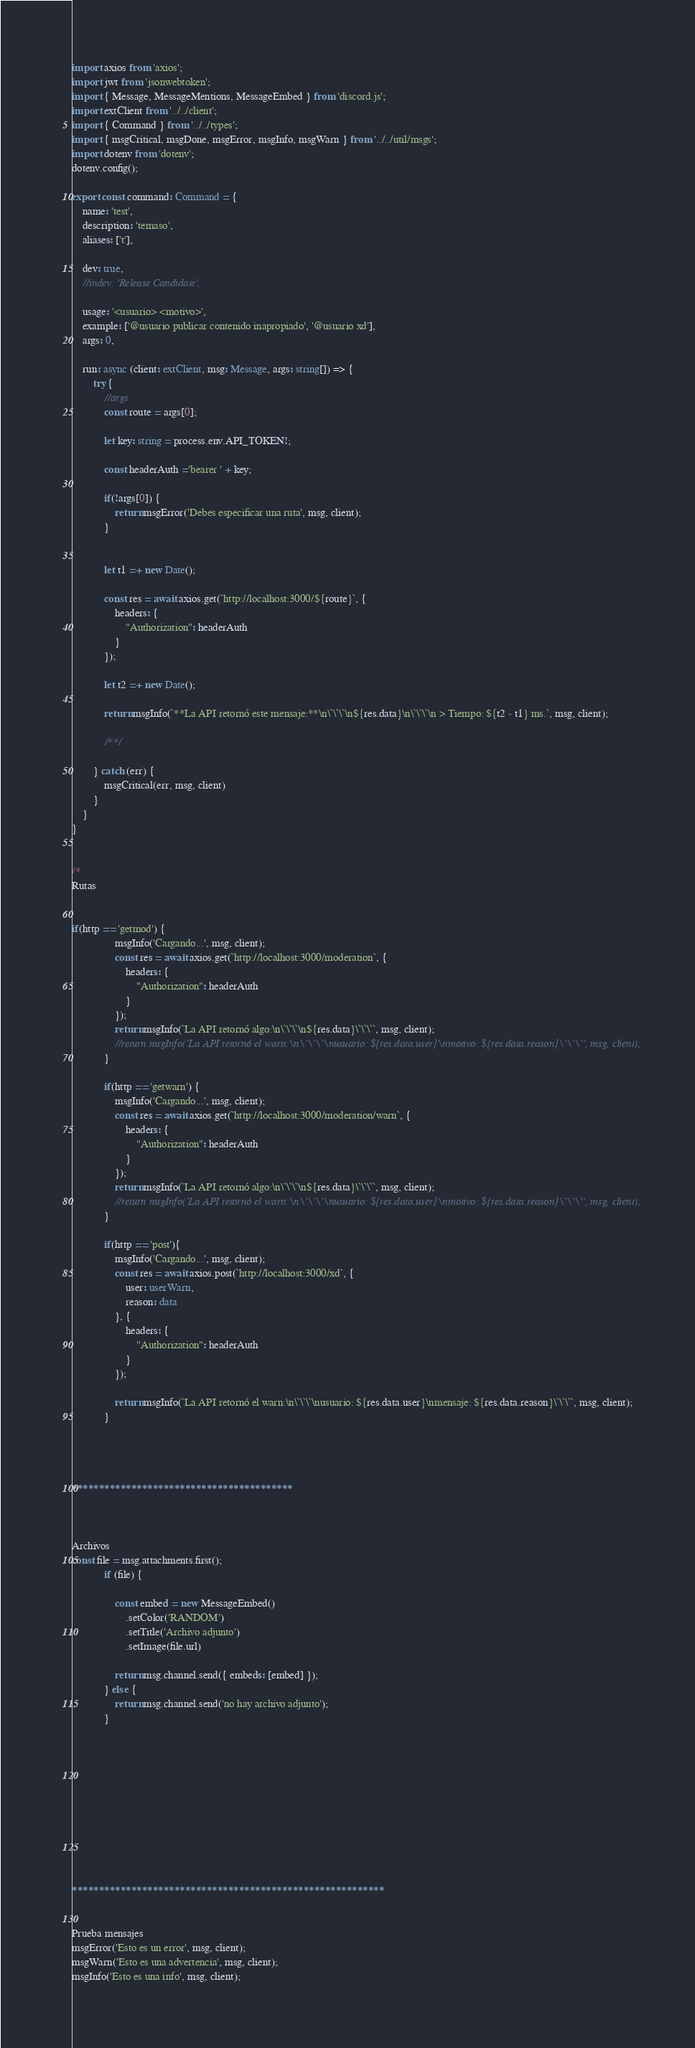<code> <loc_0><loc_0><loc_500><loc_500><_TypeScript_>import axios from 'axios';
import jwt from 'jsonwebtoken';
import { Message, MessageMentions, MessageEmbed } from 'discord.js';
import extClient from '../../client';
import { Command } from '../../types';
import { msgCritical, msgDone, msgError, msgInfo, msgWarn } from '../../util/msgs';
import dotenv from 'dotenv';
dotenv.config();

export const command: Command = {
	name: 'test',
	description: 'temaso',
	aliases: ['t'],
	
    dev: true,
	//indev: 'Release Candidate',
	
	usage: '<usuario> <motivo>',
	example: ['@usuario publicar contenido inapropiado', '@usuario xd'],
	args: 0,
	
	run: async (client: extClient, msg: Message, args: string[]) => {
		try {
			//args
			const route = args[0];

			let key: string = process.env.API_TOKEN!;
			
			const headerAuth ='bearer ' + key;
			
			if(!args[0]) {
				return msgError('Debes especificar una ruta', msg, client);
			}


			let t1 =+ new Date();

			const res = await axios.get(`http://localhost:3000/${route}`, {
				headers: {
					"Authorization": headerAuth
				}
			});

			let t2 =+ new Date();

			return msgInfo(`**La API retornó este mensaje:**\n\`\`\`\n${res.data}\n\`\`\`\n > Tiempo: ${t2 - t1} ms.`, msg, client);
			
			/**/

		} catch (err) {
			msgCritical(err, msg, client)
		}
	}
}


/*
Rutas


if(http == 'getmod') {
				msgInfo('Cargando...', msg, client);
				const res = await axios.get(`http://localhost:3000/moderation`, {
					headers: {
						"Authorization": headerAuth
					}
				});
				return msgInfo(`La API retornó algo:\n\`\`\`\n${res.data}\`\`\``, msg, client);
				//return msgInfo(`La API retornó el warn:\n\`\`\`\nusuario: ${res.data.user}\nmotivo: ${res.data.reason}\`\`\``, msg, client);
			}

			if(http == 'getwarn') {
				msgInfo('Cargando...', msg, client);
				const res = await axios.get(`http://localhost:3000/moderation/warn`, {
					headers: {
						"Authorization": headerAuth
					}
				});
				return msgInfo(`La API retornó algo:\n\`\`\`\n${res.data}\`\`\``, msg, client);
				//return msgInfo(`La API retornó el warn:\n\`\`\`\nusuario: ${res.data.user}\nmotivo: ${res.data.reason}\`\`\``, msg, client);
			}

			if(http == 'post'){
				msgInfo('Cargando...', msg, client);
				const res = await axios.post(`http://localhost:3000/xd`, {
					user: userWarn,
					reason: data
				}, {
					headers: {
						"Authorization": headerAuth
					}
				});
				
				return msgInfo(`La API retornó el warn:\n\`\`\`\nusuario: ${res.data.user}\nmensaje: ${res.data.reason}\`\`\``, msg, client);
			}




*****************************************



Archivos
const file = msg.attachments.first();
			if (file) {

				const embed = new MessageEmbed()
					.setColor('RANDOM')
					.setTitle('Archivo adjunto')
					.setImage(file.url)

				return msg.channel.send({ embeds: [embed] });
			} else {
				return msg.channel.send('no hay archivo adjunto');
			}











**********************************************************


Prueba mensajes
msgError('Esto es un error', msg, client);
msgWarn('Esto es una advertencia', msg, client);
msgInfo('Esto es una info', msg, client);</code> 